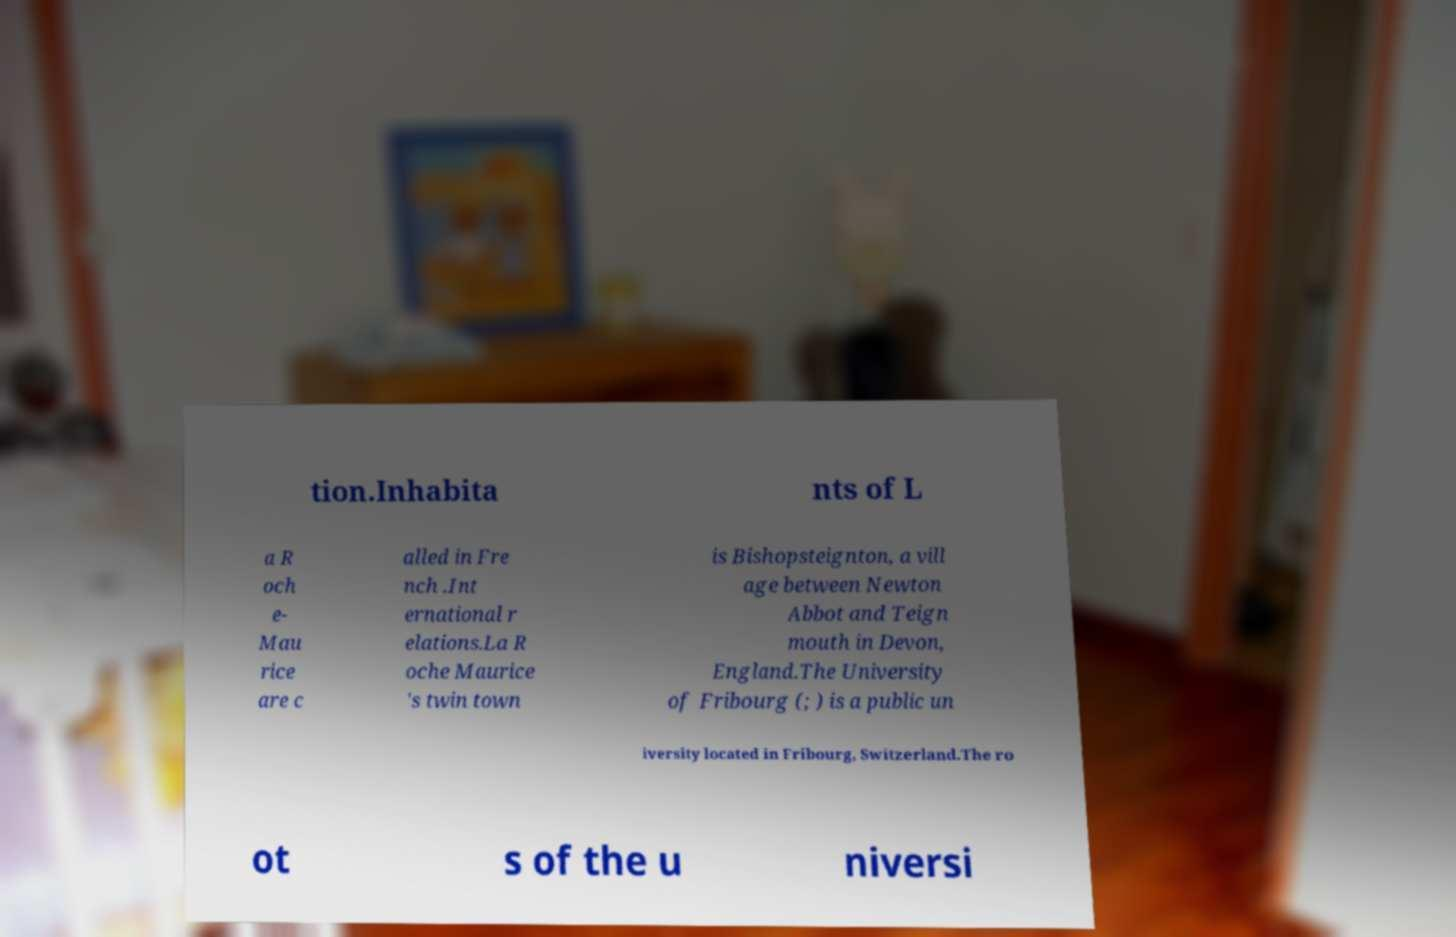What messages or text are displayed in this image? I need them in a readable, typed format. tion.Inhabita nts of L a R och e- Mau rice are c alled in Fre nch .Int ernational r elations.La R oche Maurice 's twin town is Bishopsteignton, a vill age between Newton Abbot and Teign mouth in Devon, England.The University of Fribourg (; ) is a public un iversity located in Fribourg, Switzerland.The ro ot s of the u niversi 